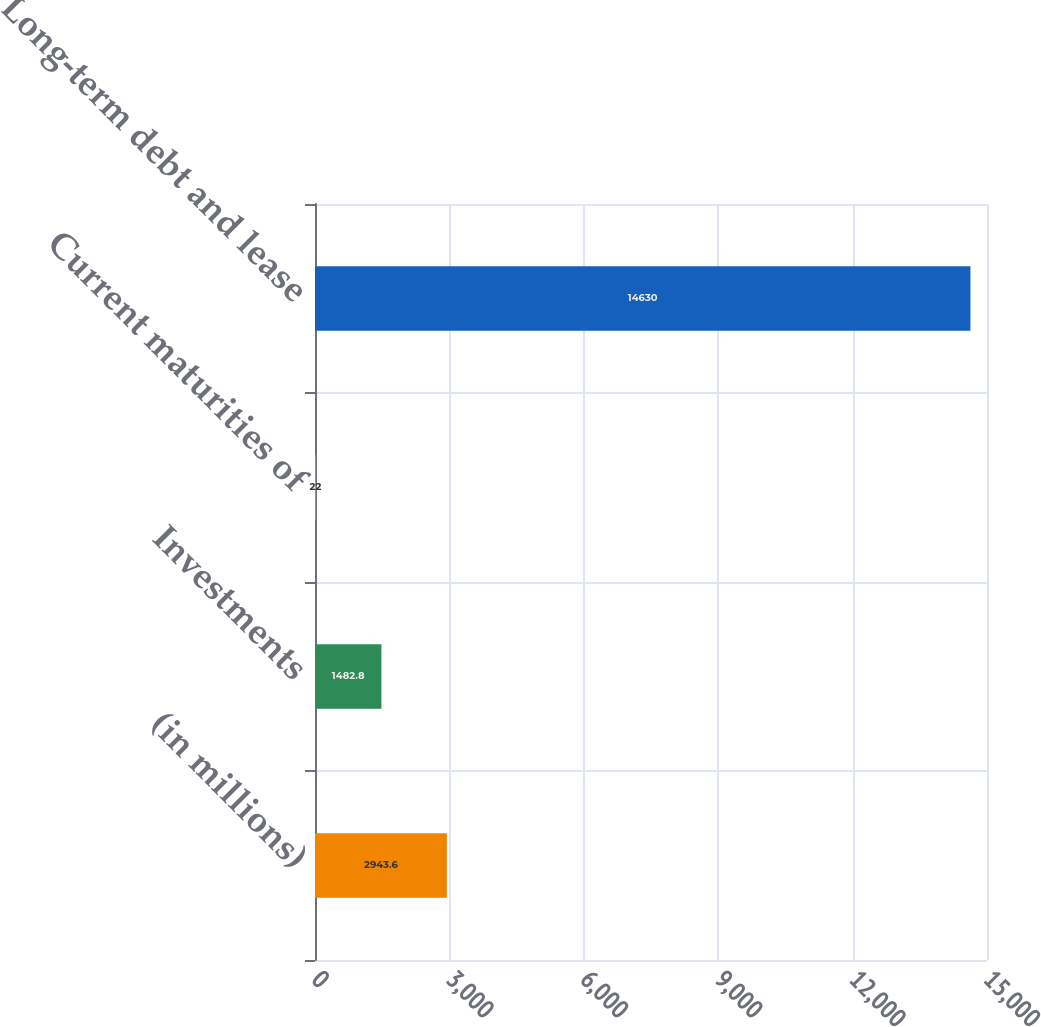Convert chart. <chart><loc_0><loc_0><loc_500><loc_500><bar_chart><fcel>(in millions)<fcel>Investments<fcel>Current maturities of<fcel>Long-term debt and lease<nl><fcel>2943.6<fcel>1482.8<fcel>22<fcel>14630<nl></chart> 